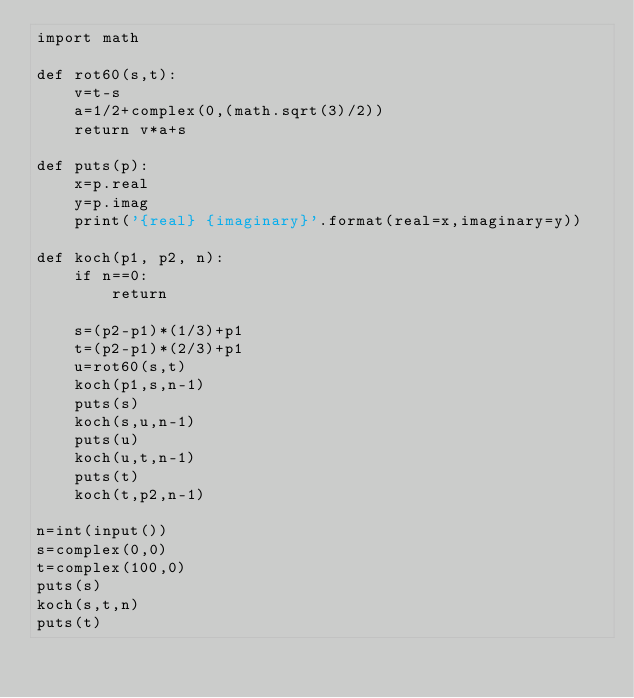<code> <loc_0><loc_0><loc_500><loc_500><_Python_>import math

def rot60(s,t):
    v=t-s
    a=1/2+complex(0,(math.sqrt(3)/2))
    return v*a+s

def puts(p):
    x=p.real
    y=p.imag
    print('{real} {imaginary}'.format(real=x,imaginary=y))

def koch(p1, p2, n):
    if n==0:
        return

    s=(p2-p1)*(1/3)+p1
    t=(p2-p1)*(2/3)+p1
    u=rot60(s,t)
    koch(p1,s,n-1)
    puts(s)
    koch(s,u,n-1)
    puts(u)
    koch(u,t,n-1)
    puts(t)
    koch(t,p2,n-1)
    
n=int(input())
s=complex(0,0)
t=complex(100,0)
puts(s)
koch(s,t,n) 
puts(t)
</code> 